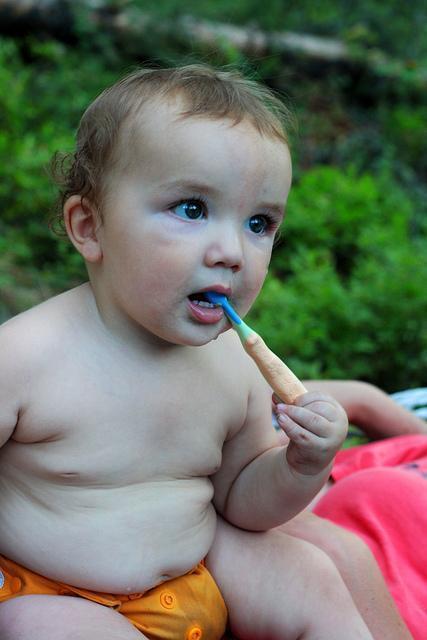How many people are in the picture?
Give a very brief answer. 1. How many giraffe are in the picture?
Give a very brief answer. 0. 